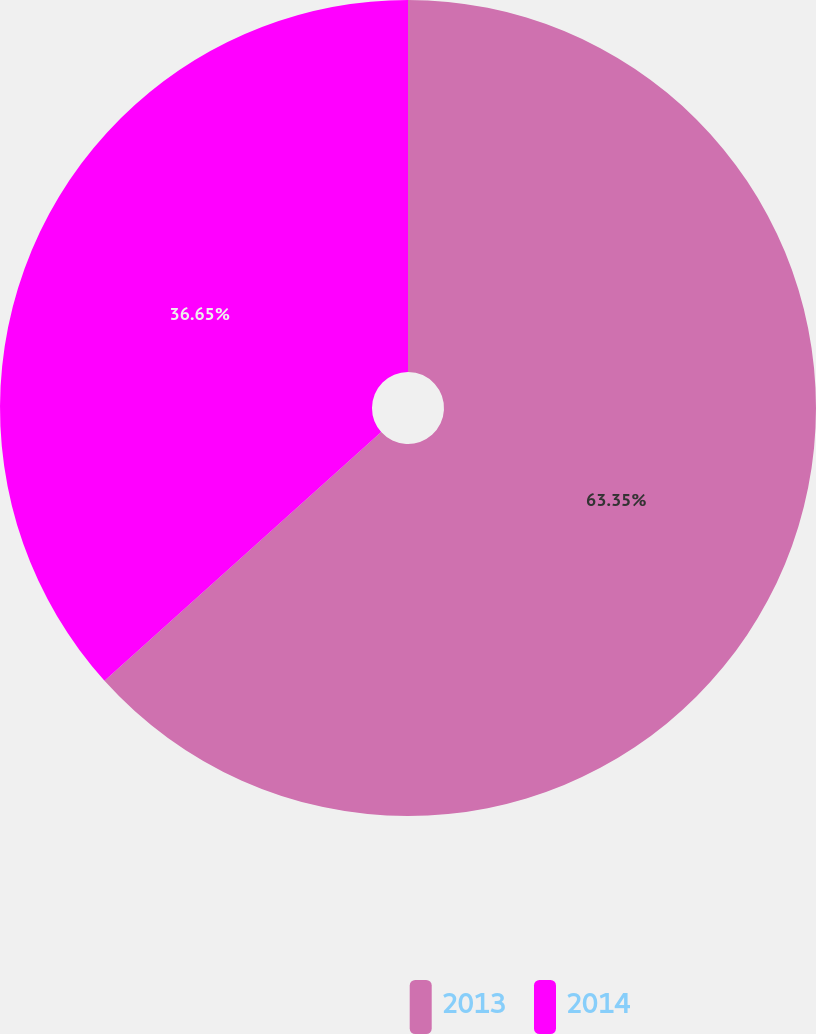<chart> <loc_0><loc_0><loc_500><loc_500><pie_chart><fcel>2013<fcel>2014<nl><fcel>63.35%<fcel>36.65%<nl></chart> 